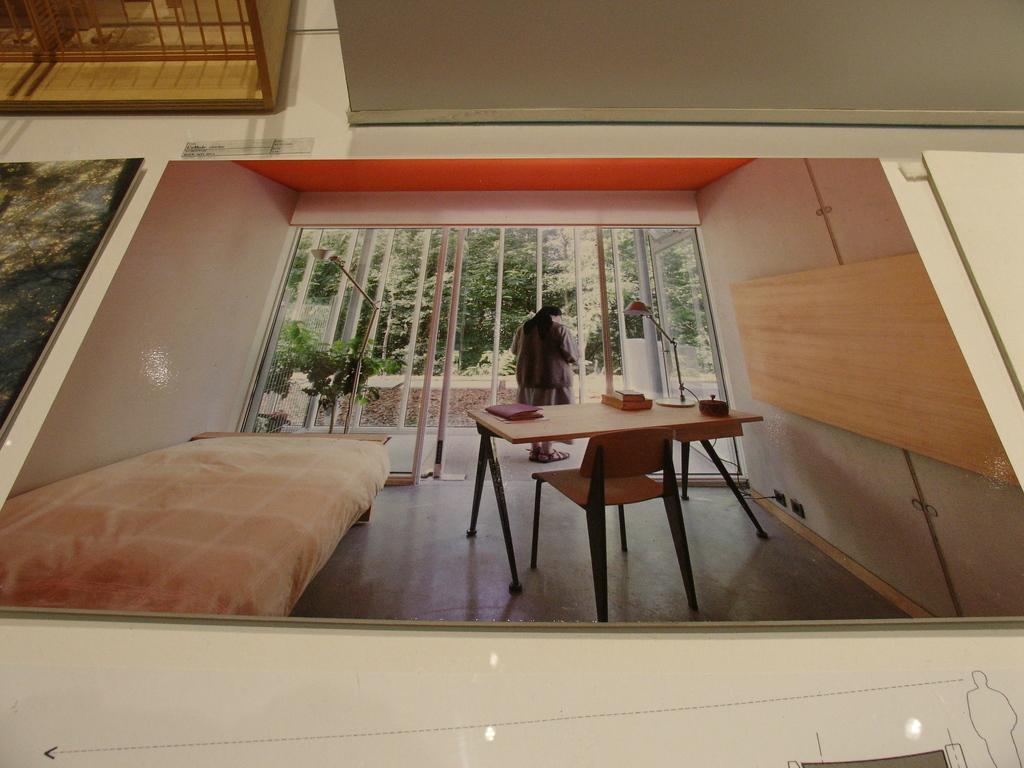Can you describe this image briefly? In this image, we can see some posts with images are placed on the surface. We can also see some objects on the top. 